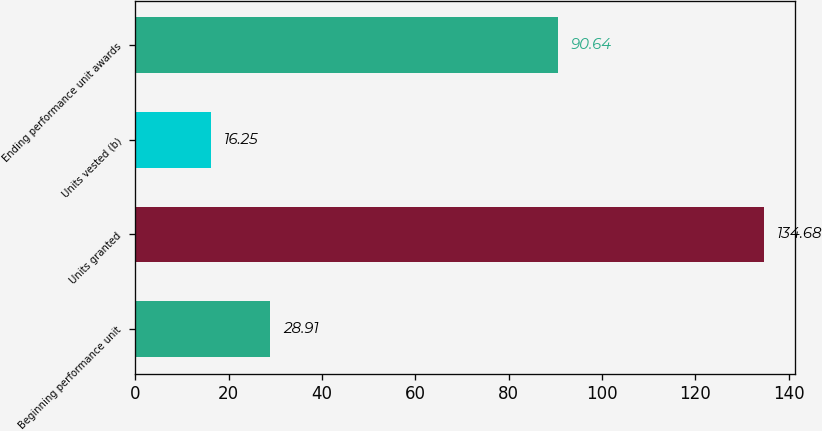Convert chart. <chart><loc_0><loc_0><loc_500><loc_500><bar_chart><fcel>Beginning performance unit<fcel>Units granted<fcel>Units vested (b)<fcel>Ending performance unit awards<nl><fcel>28.91<fcel>134.68<fcel>16.25<fcel>90.64<nl></chart> 